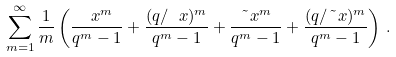Convert formula to latex. <formula><loc_0><loc_0><loc_500><loc_500>\sum _ { m = 1 } ^ { \infty } \frac { 1 } { m } \left ( \frac { \ x ^ { m } } { q ^ { m } - 1 } + \frac { ( q / \ x ) ^ { m } } { q ^ { m } - 1 } + \frac { \tilde { \ } x ^ { m } } { q ^ { m } - 1 } + \frac { ( q / \tilde { \ } x ) ^ { m } } { q ^ { m } - 1 } \right ) \, .</formula> 